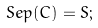Convert formula to latex. <formula><loc_0><loc_0><loc_500><loc_500>S e p ( C ) = S ;</formula> 